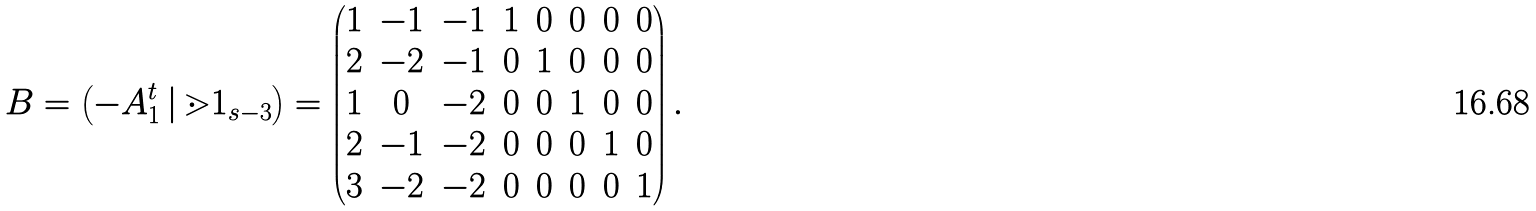Convert formula to latex. <formula><loc_0><loc_0><loc_500><loc_500>B = \left ( - A _ { 1 } ^ { t } \, | \, \mathbb { m } { 1 } _ { s - 3 } \right ) = \left ( \begin{matrix} 1 & - 1 & - 1 & 1 & 0 & 0 & 0 & 0 \\ 2 & - 2 & - 1 & 0 & 1 & 0 & 0 & 0 \\ 1 & 0 & - 2 & 0 & 0 & 1 & 0 & 0 \\ 2 & - 1 & - 2 & 0 & 0 & 0 & 1 & 0 \\ 3 & - 2 & - 2 & 0 & 0 & 0 & 0 & 1 \end{matrix} \right ) .</formula> 